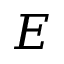Convert formula to latex. <formula><loc_0><loc_0><loc_500><loc_500>E</formula> 